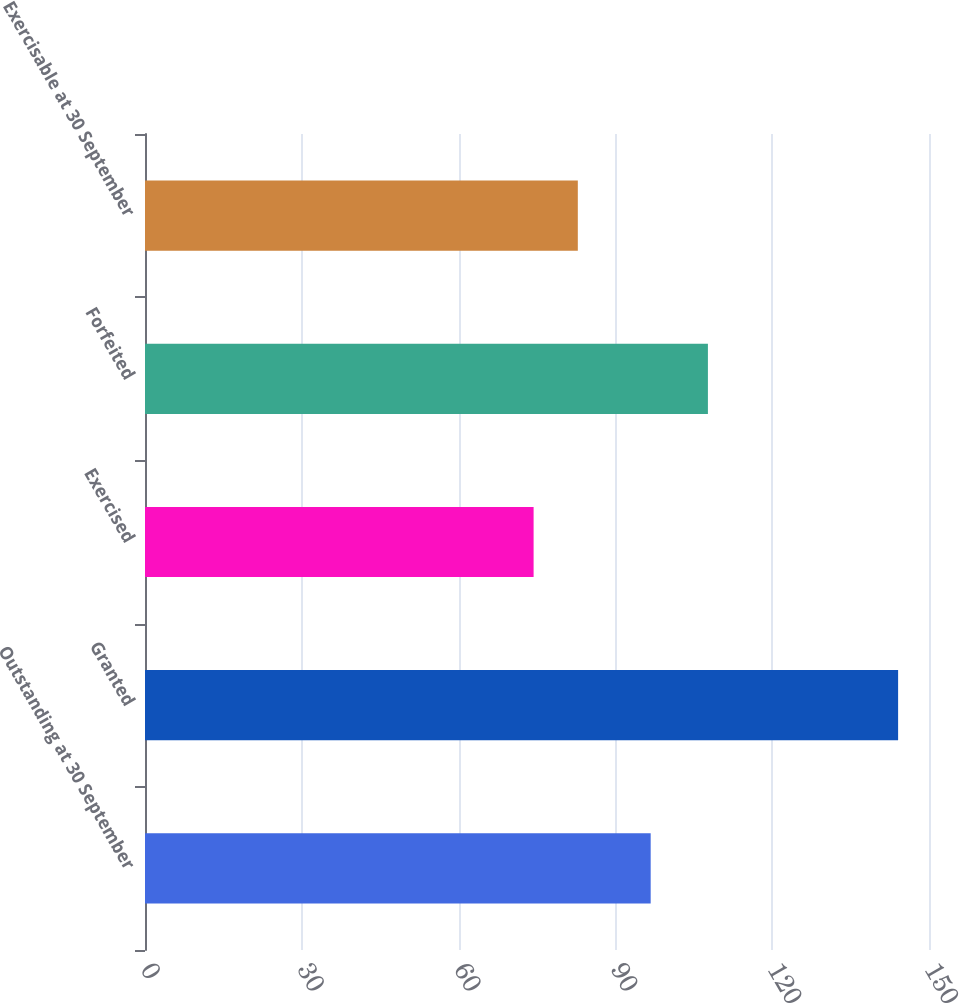<chart> <loc_0><loc_0><loc_500><loc_500><bar_chart><fcel>Outstanding at 30 September<fcel>Granted<fcel>Exercised<fcel>Forfeited<fcel>Exercisable at 30 September<nl><fcel>96.75<fcel>144.09<fcel>74.35<fcel>107.7<fcel>82.81<nl></chart> 